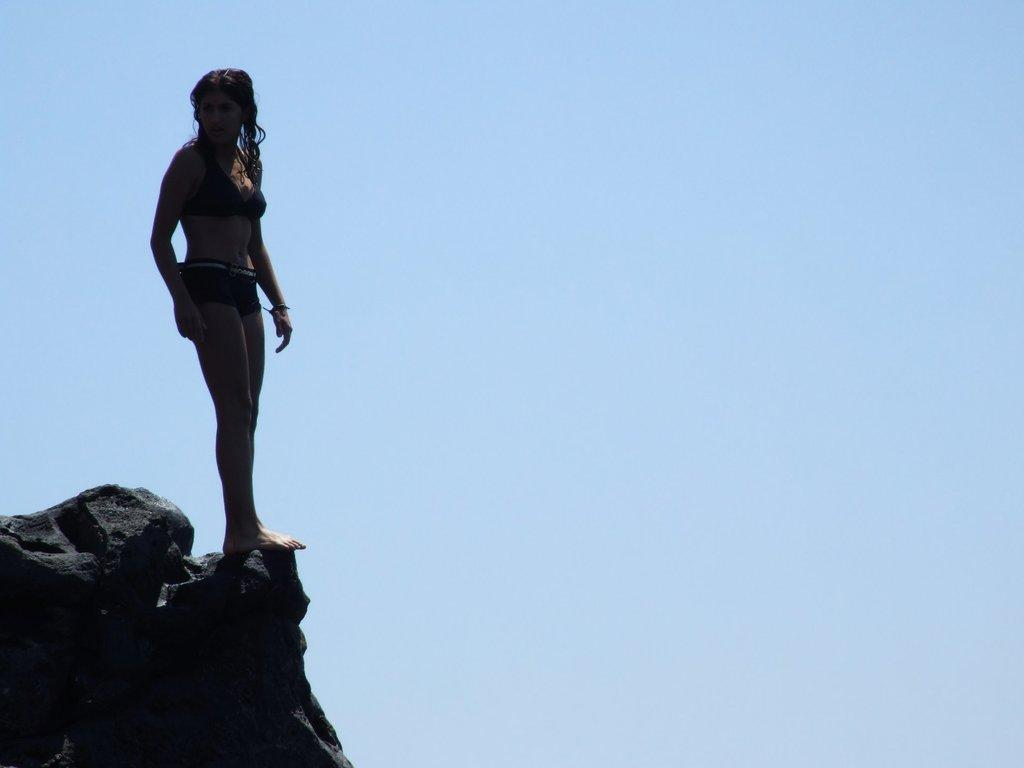Who is the main subject in the image? There is a lady in the image. What is the lady doing in the image? The lady is standing on a rock. What can be seen in the background of the image? The sky is visible in the background of the image. What type of chess piece is the lady holding in the image? There is no chess piece present in the image. What animals can be seen on the farm in the image? There is no farm present in the image. 